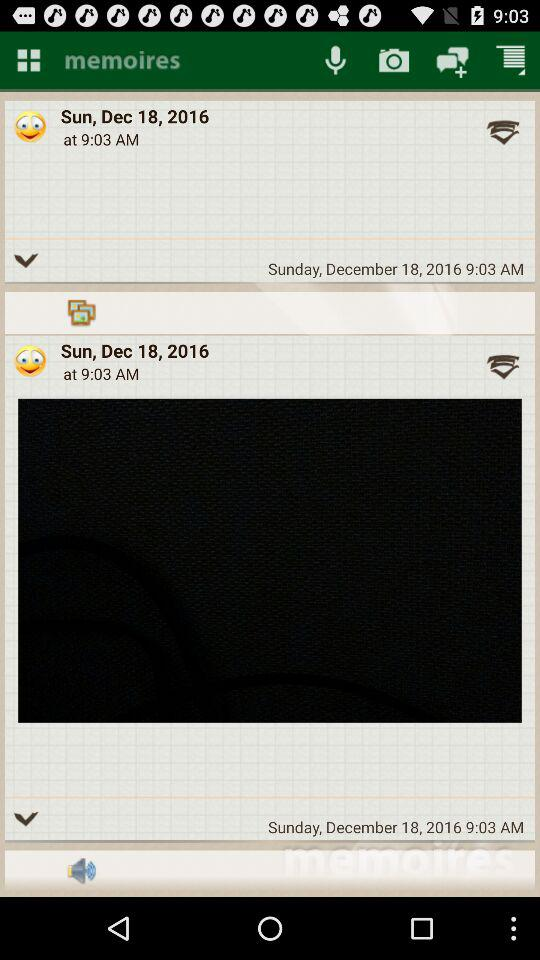What date is shown on the screen? The shown date is Sunday, December 18, 2016. 